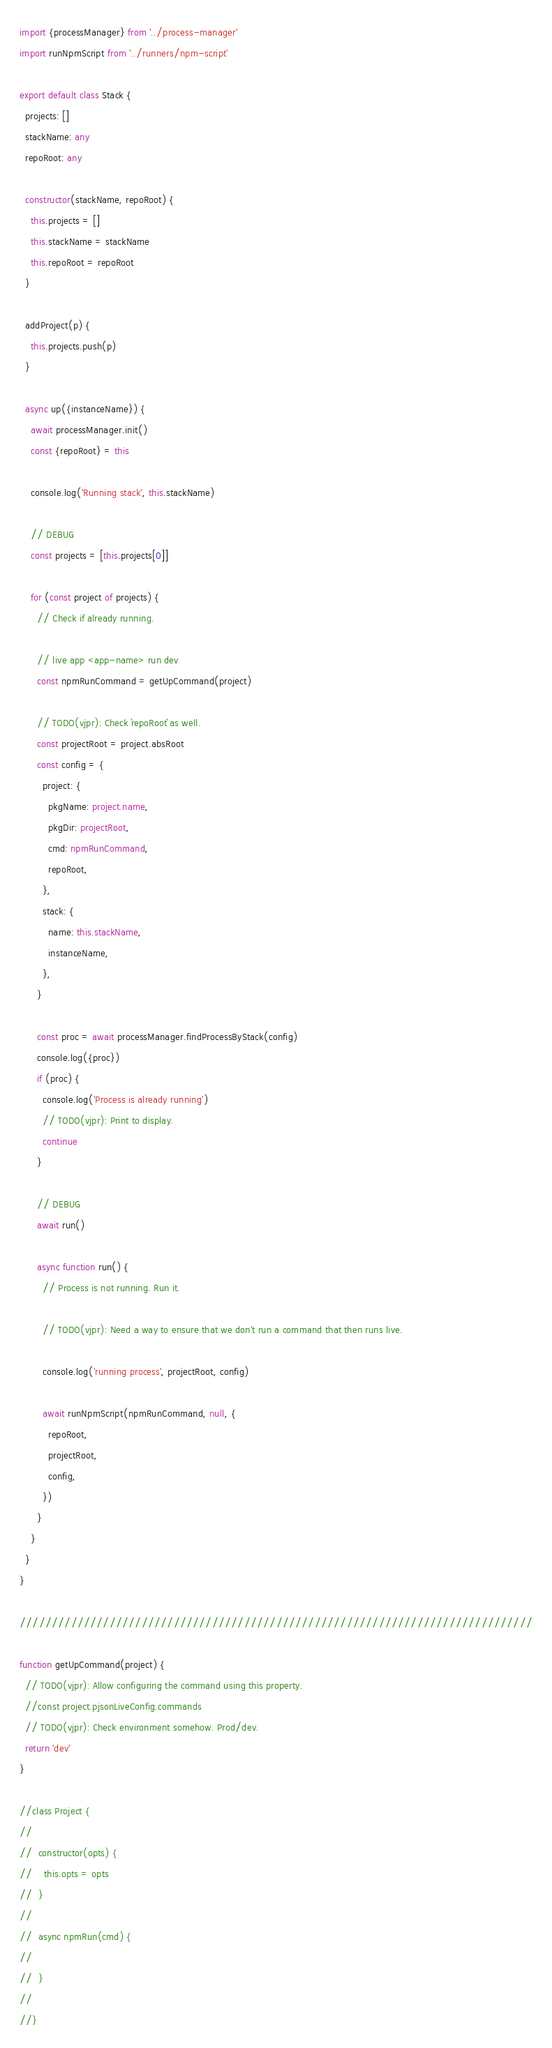Convert code to text. <code><loc_0><loc_0><loc_500><loc_500><_TypeScript_>import {processManager} from '../process-manager'
import runNpmScript from '../runners/npm-script'

export default class Stack {
  projects: []
  stackName: any
  repoRoot: any

  constructor(stackName, repoRoot) {
    this.projects = []
    this.stackName = stackName
    this.repoRoot = repoRoot
  }

  addProject(p) {
    this.projects.push(p)
  }

  async up({instanceName}) {
    await processManager.init()
    const {repoRoot} = this

    console.log('Running stack', this.stackName)

    // DEBUG
    const projects = [this.projects[0]]

    for (const project of projects) {
      // Check if already running.

      // live app <app-name> run dev
      const npmRunCommand = getUpCommand(project)

      // TODO(vjpr): Check `repoRoot` as well.
      const projectRoot = project.absRoot
      const config = {
        project: {
          pkgName: project.name,
          pkgDir: projectRoot,
          cmd: npmRunCommand,
          repoRoot,
        },
        stack: {
          name: this.stackName,
          instanceName,
        },
      }

      const proc = await processManager.findProcessByStack(config)
      console.log({proc})
      if (proc) {
        console.log('Process is already running')
        // TODO(vjpr): Print to display.
        continue
      }

      // DEBUG
      await run()

      async function run() {
        // Process is not running. Run it.

        // TODO(vjpr): Need a way to ensure that we don't run a command that then runs live.

        console.log('running process', projectRoot, config)

        await runNpmScript(npmRunCommand, null, {
          repoRoot,
          projectRoot,
          config,
        })
      }
    }
  }
}

////////////////////////////////////////////////////////////////////////////////

function getUpCommand(project) {
  // TODO(vjpr): Allow configuring the command using this property.
  //const project.pjsonLiveConfig.commands
  // TODO(vjpr): Check environment somehow. Prod/dev.
  return 'dev'
}

//class Project {
//
//  constructor(opts) {
//    this.opts = opts
//  }
//
//  async npmRun(cmd) {
//
//  }
//
//}
</code> 